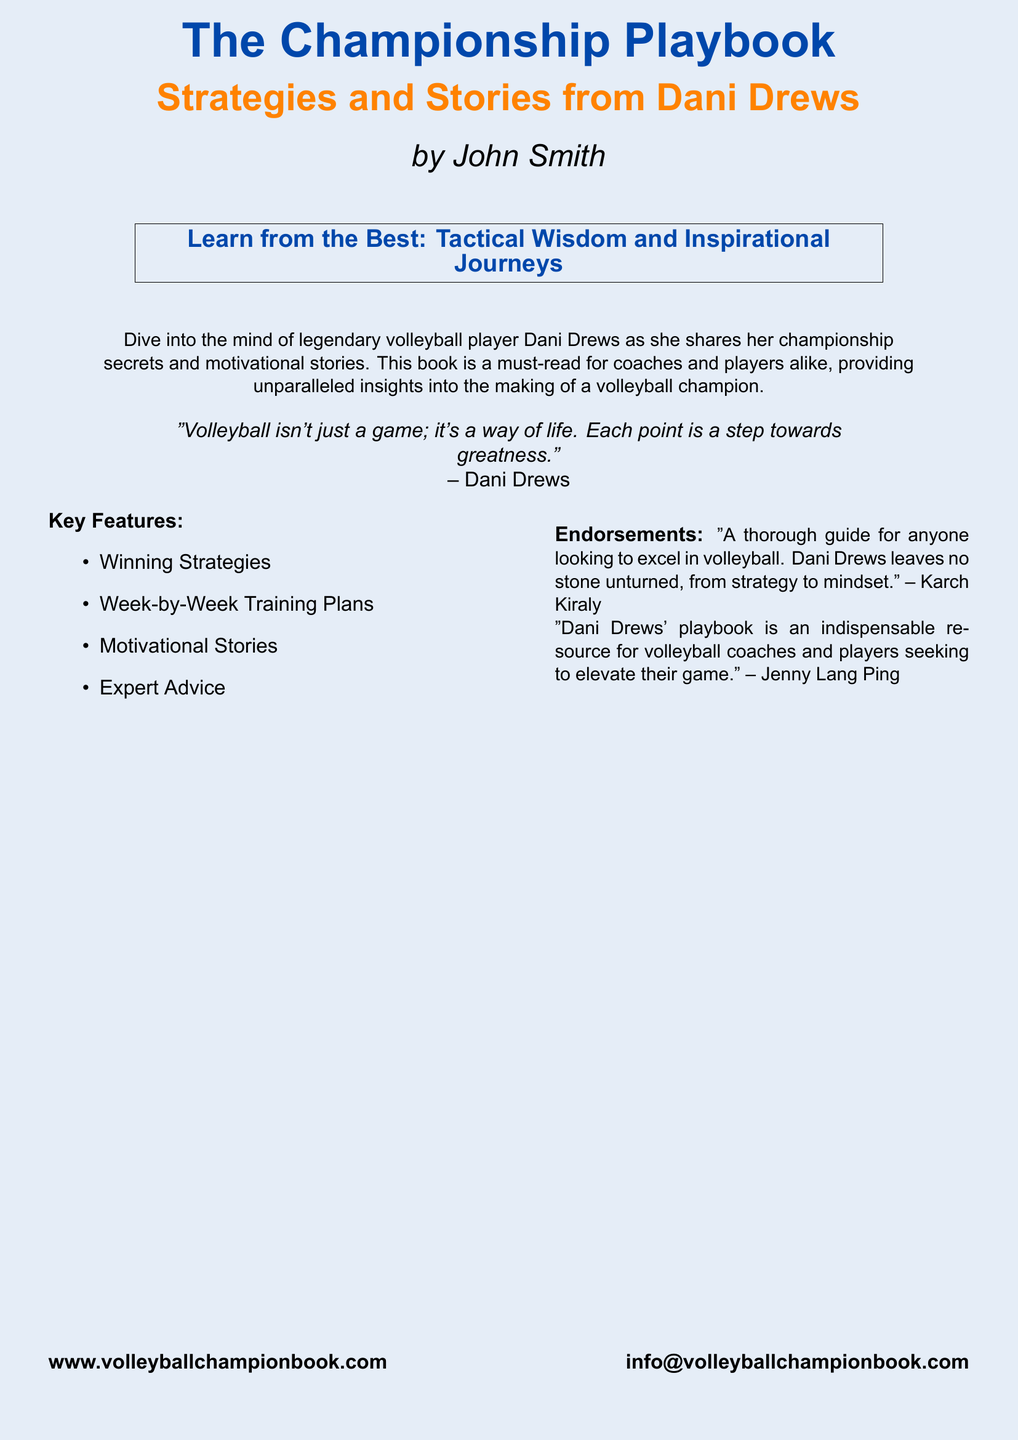What is the title of the book? The title is prominently displayed at the top of the cover.
Answer: The Championship Playbook Who is the author of the book? The author's name is listed below the title on the cover.
Answer: John Smith What color is the background of the book cover? The background color is specified in the design parameters of the document.
Answer: Volleyball blue Name one key feature of the book. The document lists several key features, providing options to select from.
Answer: Winning Strategies Who endorsed the book? Endorsements are included in a dedicated section, listing names and quotes.
Answer: Karch Kiraly What is the main purpose of the book? The main purpose is described in the introductory text.
Answer: Providing unparalleled insights into the making of a volleyball champion What does Dani Drews say about volleyball? The quote attributed to Dani Drews indicates her perspective on the sport.
Answer: "Volleyball isn't just a game; it's a way of life." What is the website for the book? The document provides the website at the bottom of the cover.
Answer: www.volleyballchampionbook.com What are the motivational stories meant for? Motivational stories serve a specific purpose mentioned in the book features.
Answer: Coaches and players 